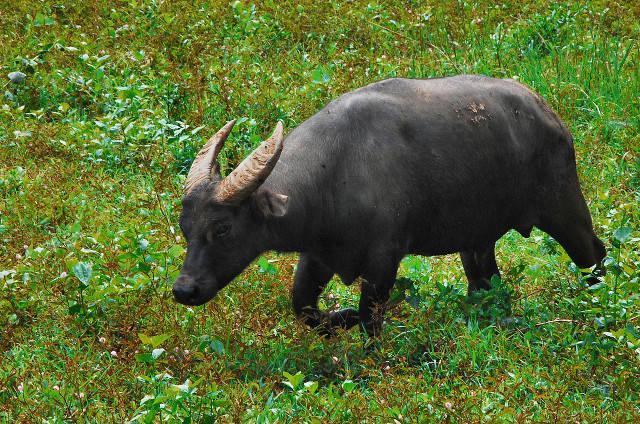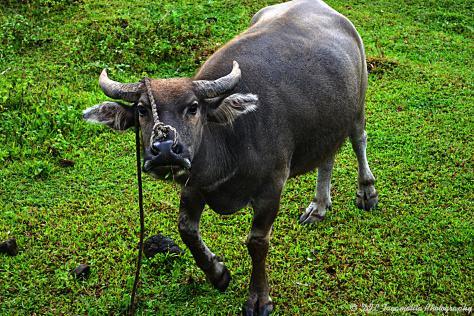The first image is the image on the left, the second image is the image on the right. Given the left and right images, does the statement "Two animals are near a small body of water." hold true? Answer yes or no. No. The first image is the image on the left, the second image is the image on the right. Given the left and right images, does the statement "Each image contains exactly one dark water buffalo, and no images contain humans." hold true? Answer yes or no. Yes. 